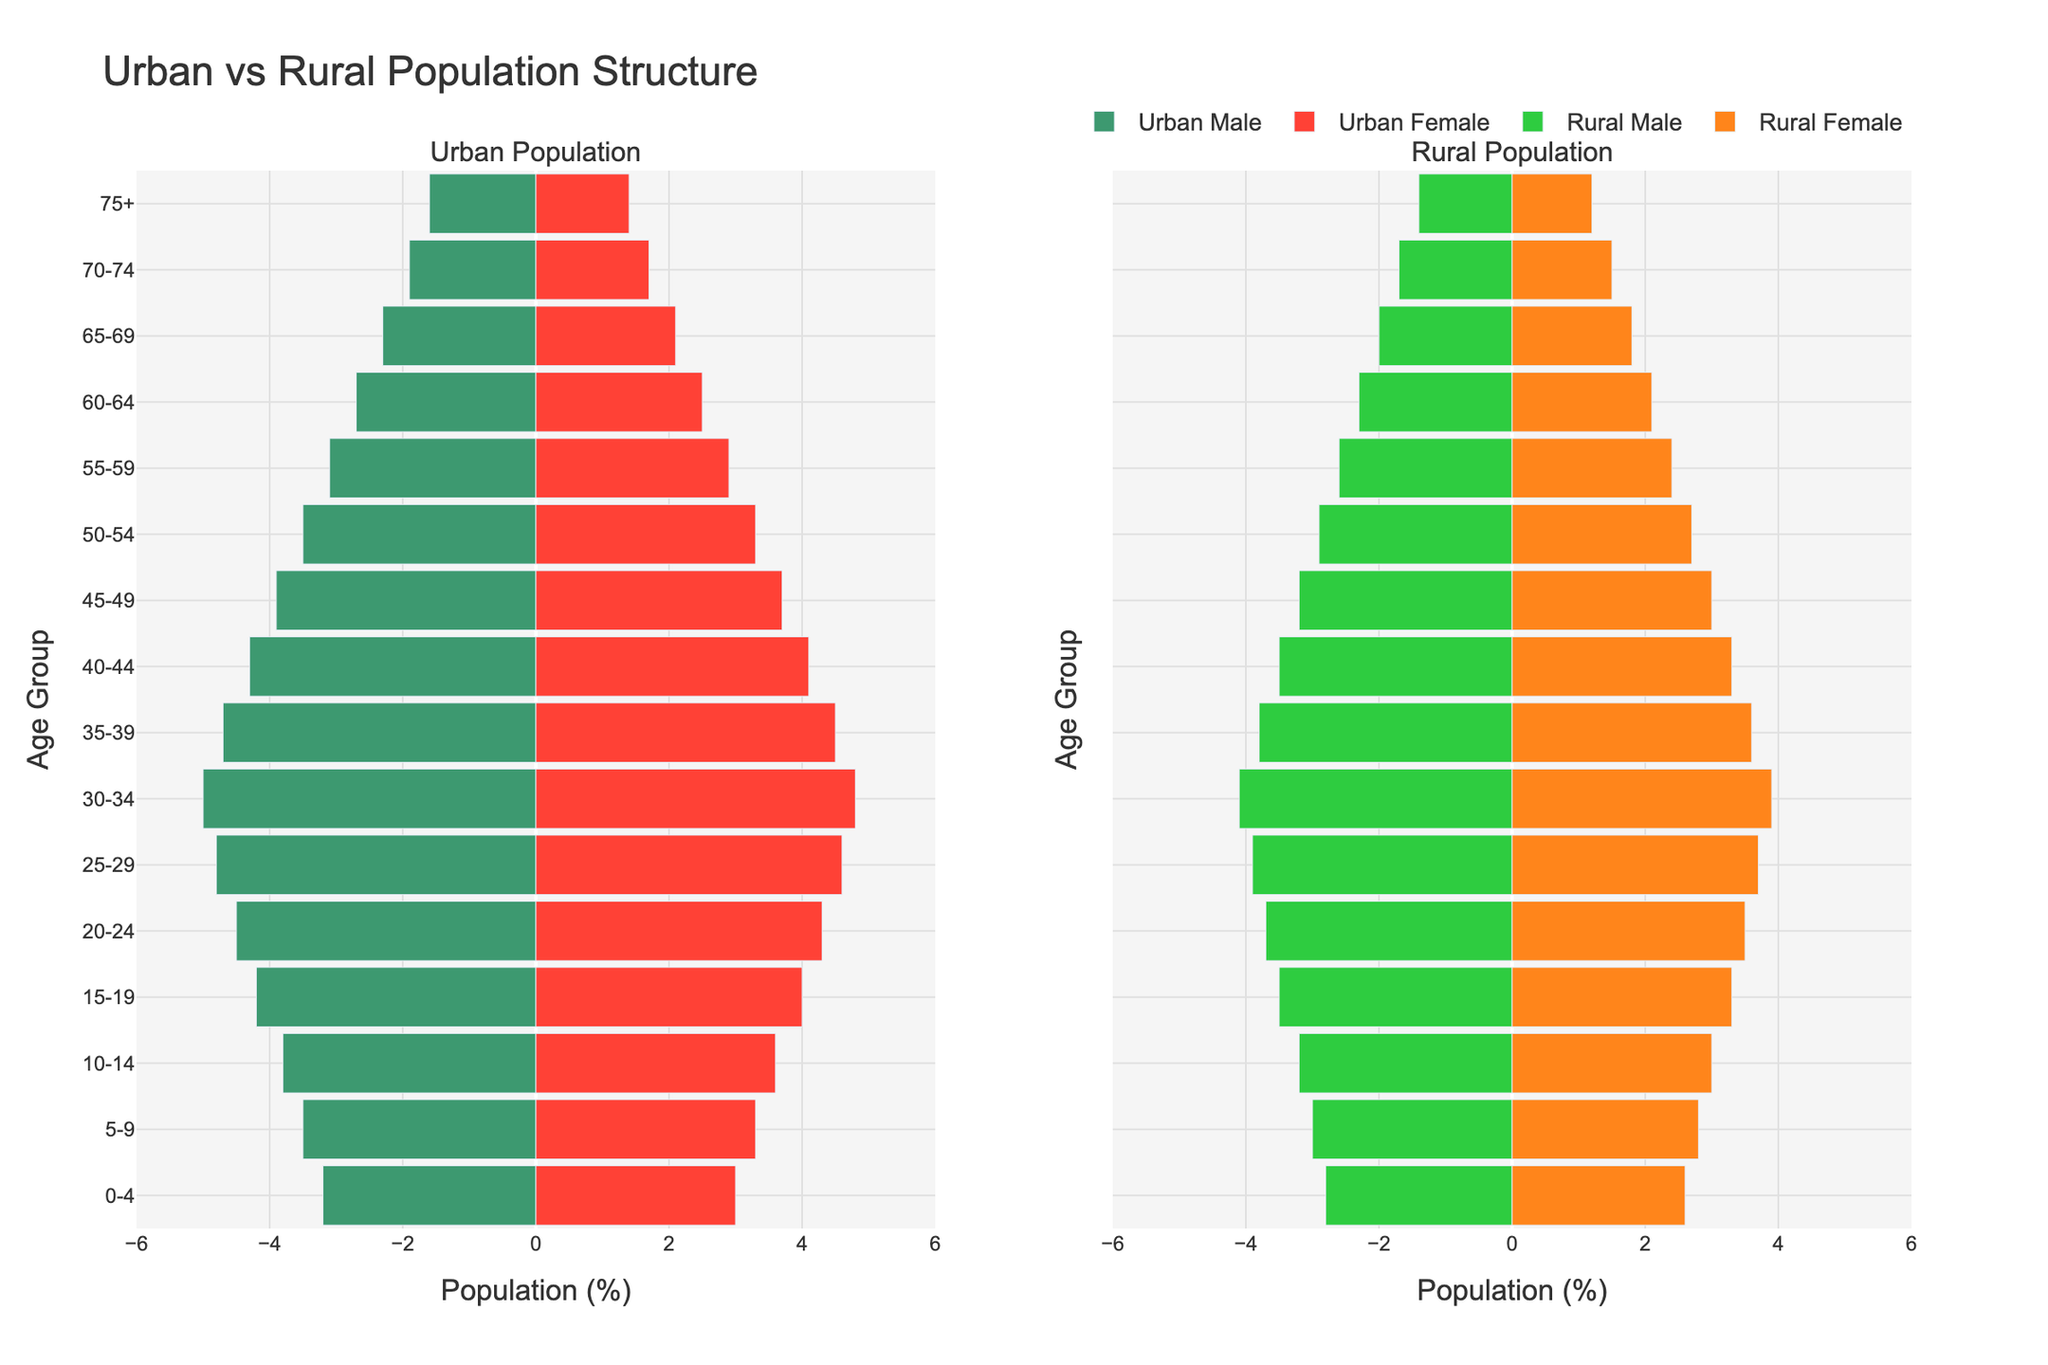What is the title of the chart? The title is found at the top of the figure. It gives a summary of what the figure represents.
Answer: Urban vs Rural Population Structure How many age groups are represented in the population pyramid? The age groups are listed on the y-axis of the figure. Count the number of unique age groups listed.
Answer: 16 Which age group has the highest percentage of urban males? Look at the left side of the Urban Population section and search for the tallest bar (which represents the highest percentage) for urban males.
Answer: 30-34 How does the percentage of rural females in the age group 30-34 compare to that of urban females in the same age group? Look at the right side of the Rural Population section and find the bar for females in the 30-34 age group. Then compare its height with the corresponding bar on the left side of the Urban Population section.
Answer: Urban females have a higher percentage What is the difference in the percentage of urban males and rural males in the age group 20-24? Find the bars corresponding to urban males and rural males in the 20-24 age group. Measure the difference between the two percentages.
Answer: 0.8% Which gender has a higher percentage in the rural population for the age group 50-54? Compare the lengths of the bars for rural males and rural females in the 50-54 age group on the right side of the figure.
Answer: Rural males What percentage of the urban population in the age group 70-74 are females? Look at the Urban Population section on the left. Identify the bar for urban females in the 70-74 age group. The length of this bar represents the percentage.
Answer: 1.7% How does the population distribution of the age group 75+ compare between urban and rural areas for females? Observe the length of the bars for urban females and rural females in the 75+ age group. Compare their lengths to understand the difference in percentages.
Answer: Urban females have a higher percentage In which age group is the gender difference (percentage difference between males and females) most pronounced in the urban population? Look within the Urban Population section and calculate the difference between the urban male and urban female bars for each age group. Identify the age group with the largest difference.
Answer: 30-34 What is the average percentage of rural females across all age groups? Add the percentages of rural females for all age groups, then divide the sum by the number of age groups to find the average.
Answer: 2.93% 